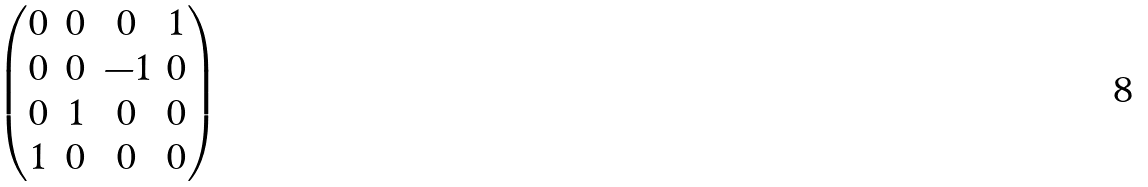<formula> <loc_0><loc_0><loc_500><loc_500>\begin{pmatrix} 0 & 0 & 0 & 1 \\ 0 & 0 & - 1 & 0 \\ 0 & 1 & 0 & 0 \\ 1 & 0 & 0 & 0 \end{pmatrix}</formula> 